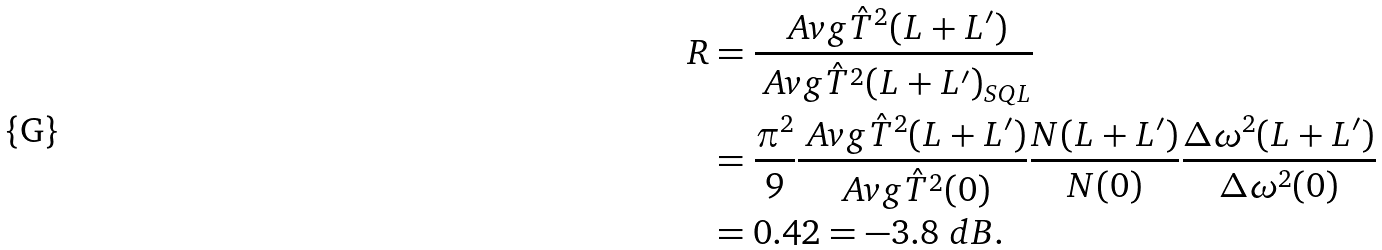<formula> <loc_0><loc_0><loc_500><loc_500>R & = \frac { \ A v g { \hat { T } ^ { 2 } ( L + L ^ { \prime } ) } } { \ A v g { \hat { T } ^ { 2 } ( L + L ^ { \prime } ) } _ { S Q L } } \\ & = \frac { \pi ^ { 2 } } { 9 } \frac { \ A v g { \hat { T } ^ { 2 } ( L + L ^ { \prime } ) } } { \ A v g { \hat { T } ^ { 2 } ( 0 ) } } \frac { N ( L + L ^ { \prime } ) } { N ( 0 ) } \frac { \Delta \omega ^ { 2 } ( L + L ^ { \prime } ) } { \Delta \omega ^ { 2 } ( 0 ) } \\ & = 0 . 4 2 = - 3 . 8 \ d B .</formula> 